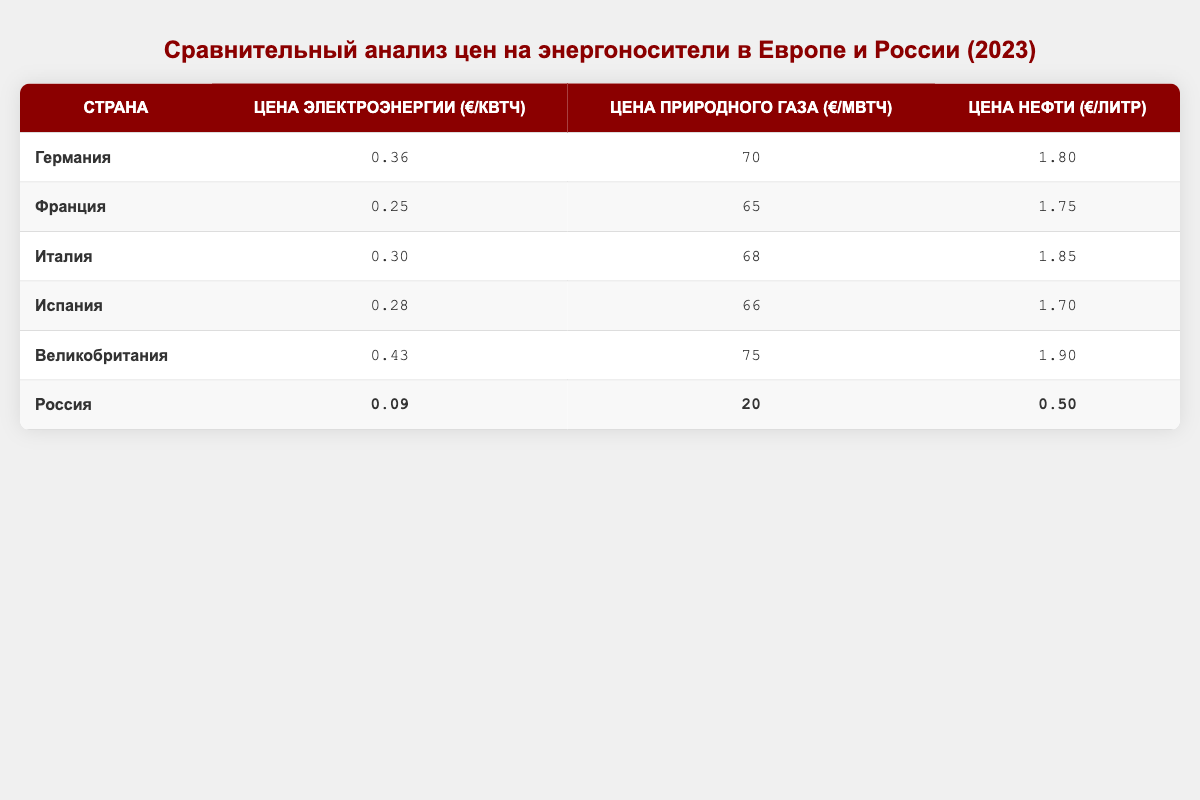What is the electricity price per kWh in Russia? The table shows the electricity price for Russia as 0.09 €/kWh.
Answer: 0.09 €/kWh Which country has the highest oil price per liter? Looking through the table, the highest oil price is listed for the United Kingdom at 1.90 €/liter.
Answer: United Kingdom What is the natural gas price per MWh in Germany? The table indicates that the natural gas price in Germany is 70 €/MWh.
Answer: 70 €/MWh Calculate the average electricity price per kWh for all the countries listed. To calculate the average: (0.36 + 0.25 + 0.30 + 0.28 + 0.43 + 0.09) / 6 = 0.28. Thus, the average electricity price per kWh is 0.28 €.
Answer: 0.28 €/kWh Is the electricity price in France higher than in Italy? The electricity price in France is 0.25 €/kWh, while in Italy it is 0.30 €/kWh. Since 0.25 < 0.30, the statement is false.
Answer: No What is the difference in natural gas prices between the United Kingdom and Russia? The natural gas price in the United Kingdom is 75 €/MWh and in Russia, it is 20 €/MWh. The difference is 75 - 20 = 55 €/MWh.
Answer: 55 €/MWh Which countries have a cheaper oil price than Russia? Russia's oil price is 0.50 €/liter. The countries with lower oil prices are Spain (1.70), France (1.75), and Italy (1.85). All others are higher.
Answer: Spain, France, Italy What percentage of the highest electricity price (United Kingdom) does Russia's electricity price represent? The highest electricity price is 0.43 € (UK), and Russia's is 0.09 €. The percentage is (0.09 / 0.43) * 100 ≈ 20.93%.
Answer: Approximately 20.93% Which country has the lowest overall energy prices (considering electricity, natural gas, and oil)? Comparing all three types of energy prices for each country, Russia has the lowest prices across the board (0.09, 20, 0.50).
Answer: Russia Is the total energy price sum in Germany greater than in Spain? The total energy price sum in Germany is 0.36 + 70 + 1.80 = 72.16; in Spain, it is 0.28 + 66 + 1.70 = 68.98. Since 72.16 > 68.98, the statement is true.
Answer: Yes 